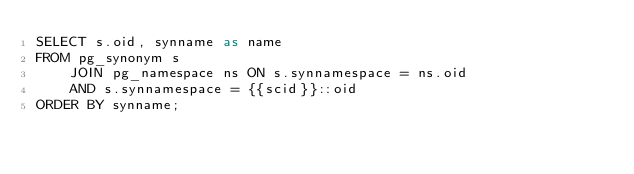Convert code to text. <code><loc_0><loc_0><loc_500><loc_500><_SQL_>SELECT s.oid, synname as name
FROM pg_synonym s
    JOIN pg_namespace ns ON s.synnamespace = ns.oid
    AND s.synnamespace = {{scid}}::oid
ORDER BY synname;
</code> 